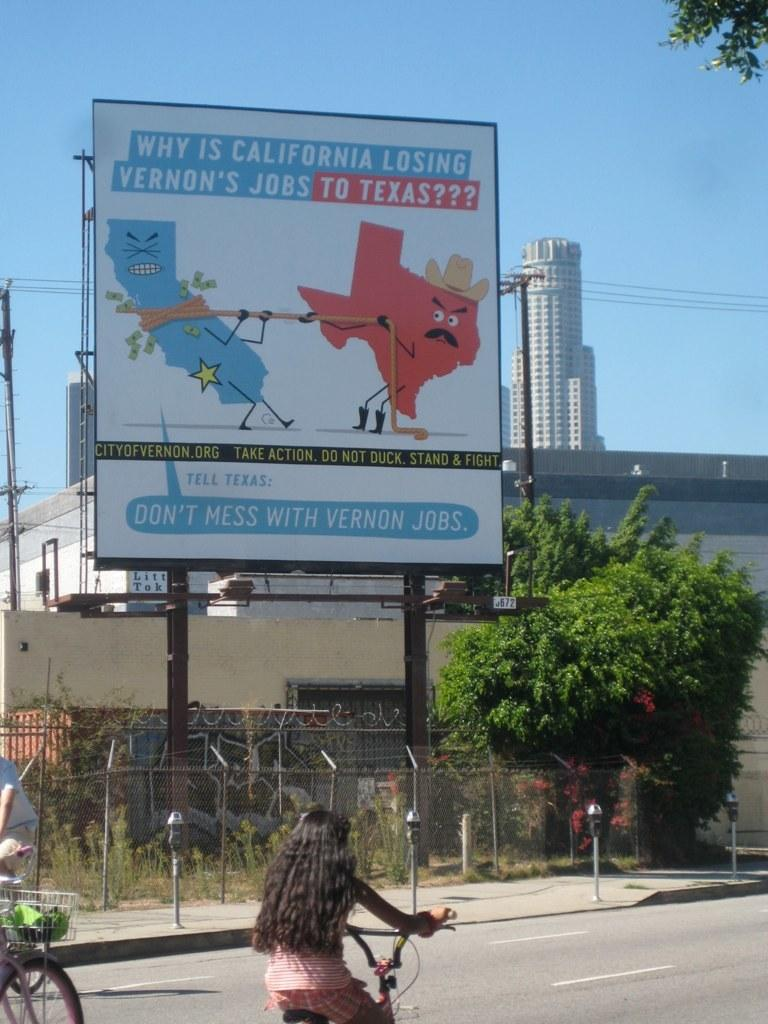<image>
Present a compact description of the photo's key features. A billboard advises you to tell Texas Don't Mess With Vernon Jobs. 